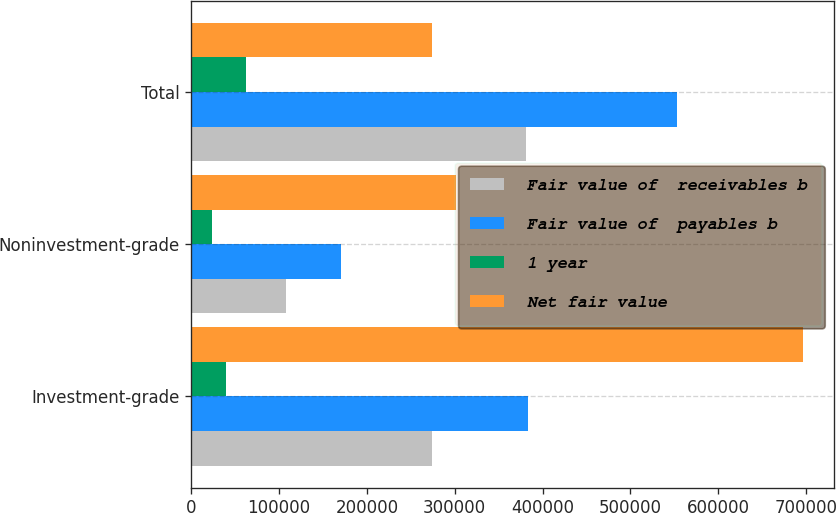Convert chart. <chart><loc_0><loc_0><loc_500><loc_500><stacked_bar_chart><ecel><fcel>Investment-grade<fcel>Noninvestment-grade<fcel>Total<nl><fcel>Fair value of  receivables b<fcel>273688<fcel>107955<fcel>381643<nl><fcel>Fair value of  payables b<fcel>383586<fcel>170046<fcel>553632<nl><fcel>1 year<fcel>39281<fcel>23317<fcel>62598<nl><fcel>Net fair value<fcel>696555<fcel>301318<fcel>273688<nl></chart> 